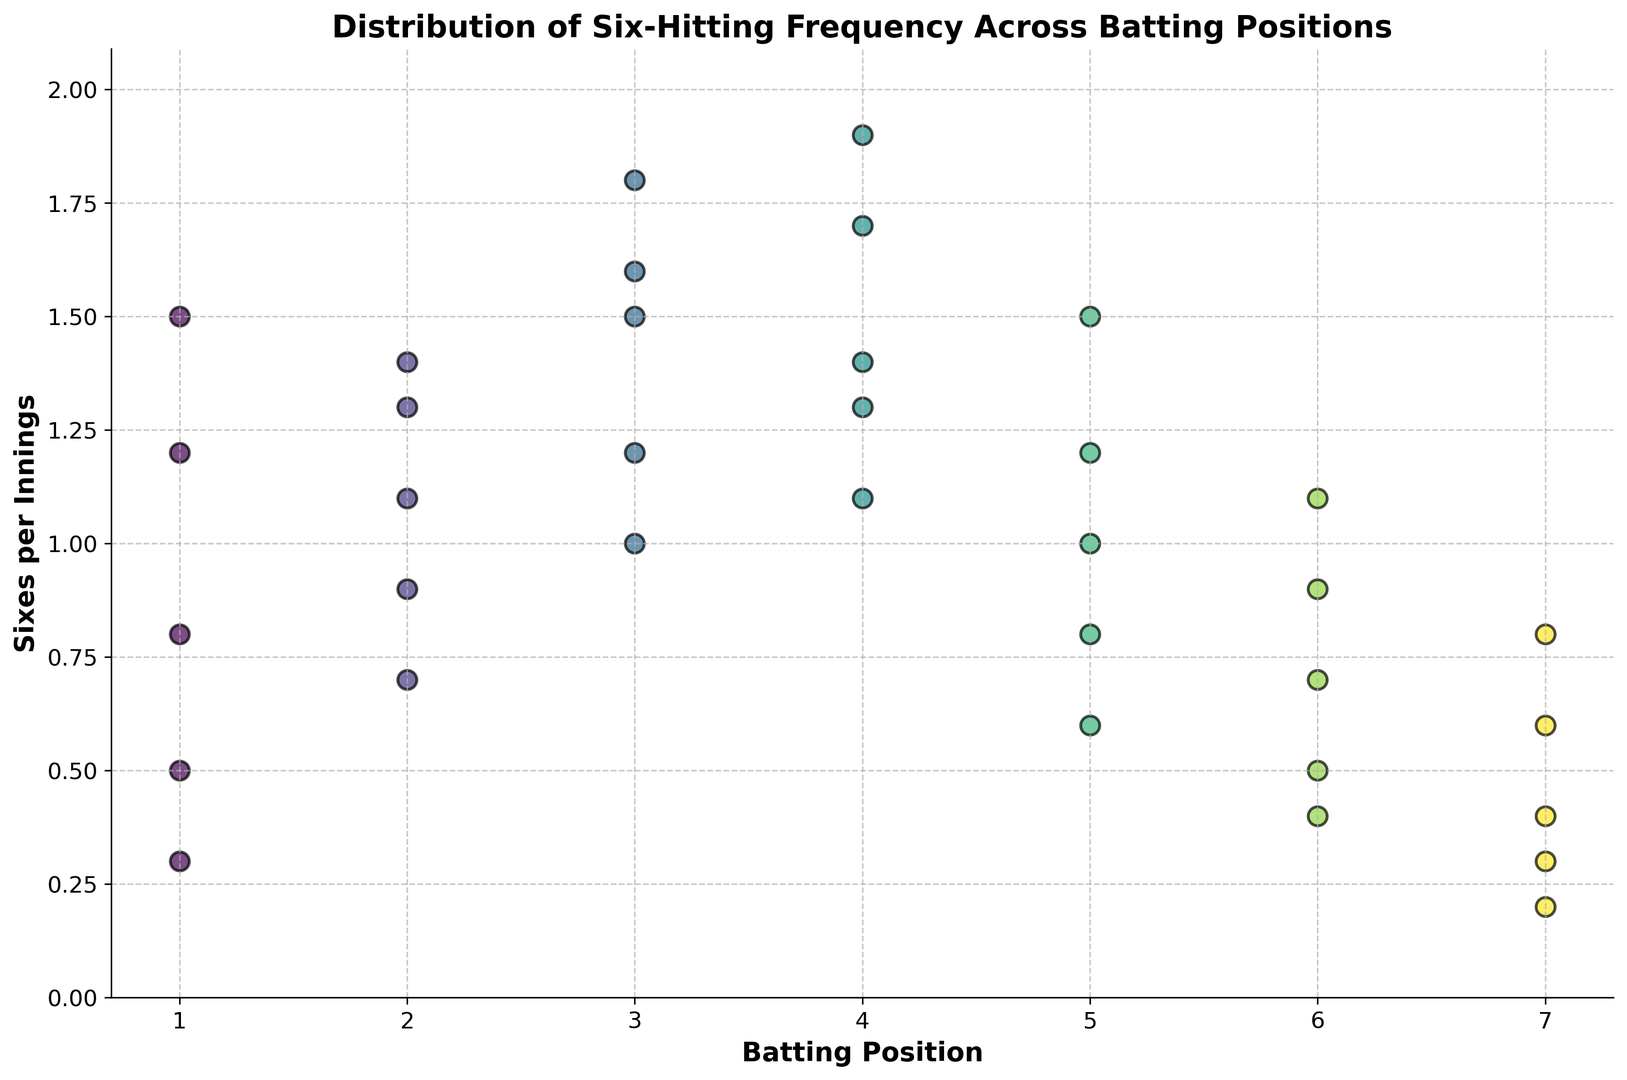Which batting position has the highest average sixes per innings? Identify the y-values for each batting position and calculate the average for each. Position 3 has the highest average of 1.42 (calculated as (1.6+1.2+1.8+1.0+1.5)/5).
Answer: Position 3 What is the range of sixes per innings for the opening batsman (position 1)? Find the minimum and maximum values for batting position 1. It ranges from 0.3 to 1.5 sixes per innings.
Answer: 0.3 to 1.5 How do the six-hitting frequencies for positions 5 and 6 compare? Compare the spread and average values for positions 5 and 6. Position 5 ranges from 0.6 to 1.5, while position 6 ranges from 0.4 to 1.1, showing position 5 has both higher spread and average.
Answer: Position 5 has higher spread and average Between which batting positions is the variability in six-hitting frequency the highest? Determine the range (max-min) of sixes per innings for each position. Position 1 has the highest variability with a range from 0.3 to 1.5, i.e., a variability of 1.2.
Answer: Position 1 Which positions have at least one innings where sixes per innings is greater than 1.0? Identify positions where any data point is greater than 1.0. Positions 1, 2, 3, 4, 5, and 6 all have at least one data point greater than 1.0.
Answer: Positions 1, 2, 3, 4, 5, 6 What is the total number of innings observed for each batting position? Count the number of data points for each position: Position 1 (5), Position 2 (5), Position 3 (5), Position 4 (5), Position 5 (5), Position 6 (5), Position 7 (5).
Answer: 5 innings each Is there any batting position where an innings has sixes per innings below 0.5? Check each batting position for any values below 0.5. Positions 1, 6 and 7 have innings with sixes per innings below 0.5.
Answer: Positions 1, 6, 7 What is the median sixes per innings for batting position 4? Sort the values for position 4 and find the middle value. Values are 1.1, 1.3, 1.4, 1.7, 1.9. The median is 1.4.
Answer: 1.4 